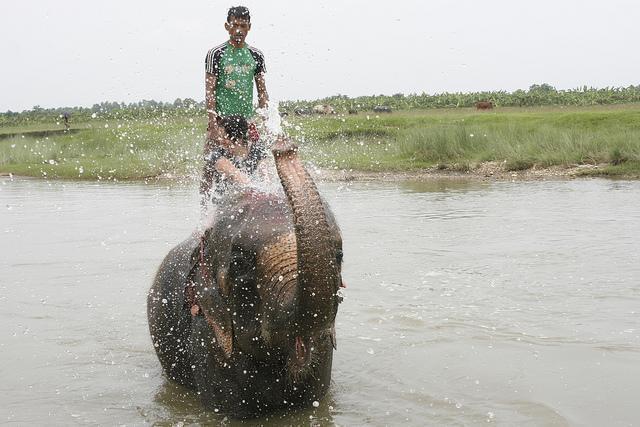How many people are on the elephant?
Give a very brief answer. 2. How many people are in the picture?
Give a very brief answer. 2. 